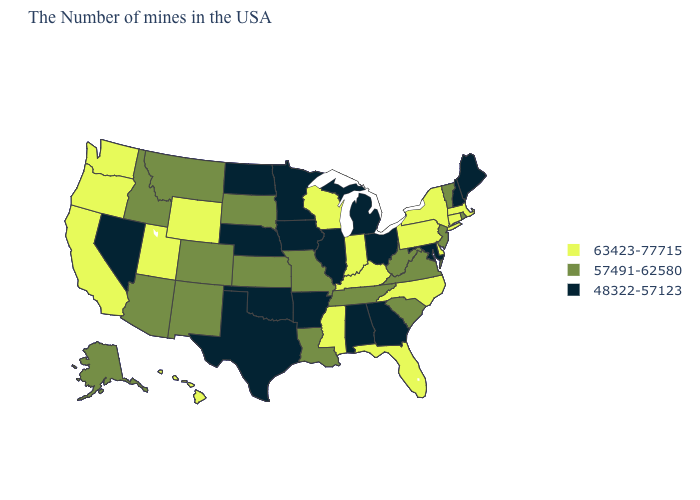Name the states that have a value in the range 63423-77715?
Short answer required. Massachusetts, Connecticut, New York, Delaware, Pennsylvania, North Carolina, Florida, Kentucky, Indiana, Wisconsin, Mississippi, Wyoming, Utah, California, Washington, Oregon, Hawaii. What is the highest value in the USA?
Quick response, please. 63423-77715. Which states have the lowest value in the USA?
Answer briefly. Maine, New Hampshire, Maryland, Ohio, Georgia, Michigan, Alabama, Illinois, Arkansas, Minnesota, Iowa, Nebraska, Oklahoma, Texas, North Dakota, Nevada. What is the value of Hawaii?
Be succinct. 63423-77715. Among the states that border Oklahoma , does Arkansas have the highest value?
Be succinct. No. Does the first symbol in the legend represent the smallest category?
Concise answer only. No. What is the value of Mississippi?
Keep it brief. 63423-77715. Name the states that have a value in the range 48322-57123?
Short answer required. Maine, New Hampshire, Maryland, Ohio, Georgia, Michigan, Alabama, Illinois, Arkansas, Minnesota, Iowa, Nebraska, Oklahoma, Texas, North Dakota, Nevada. What is the value of Arizona?
Answer briefly. 57491-62580. Name the states that have a value in the range 63423-77715?
Be succinct. Massachusetts, Connecticut, New York, Delaware, Pennsylvania, North Carolina, Florida, Kentucky, Indiana, Wisconsin, Mississippi, Wyoming, Utah, California, Washington, Oregon, Hawaii. Among the states that border Montana , does Wyoming have the highest value?
Concise answer only. Yes. What is the highest value in states that border Massachusetts?
Answer briefly. 63423-77715. What is the lowest value in the West?
Keep it brief. 48322-57123. What is the value of Georgia?
Short answer required. 48322-57123. Name the states that have a value in the range 63423-77715?
Short answer required. Massachusetts, Connecticut, New York, Delaware, Pennsylvania, North Carolina, Florida, Kentucky, Indiana, Wisconsin, Mississippi, Wyoming, Utah, California, Washington, Oregon, Hawaii. 